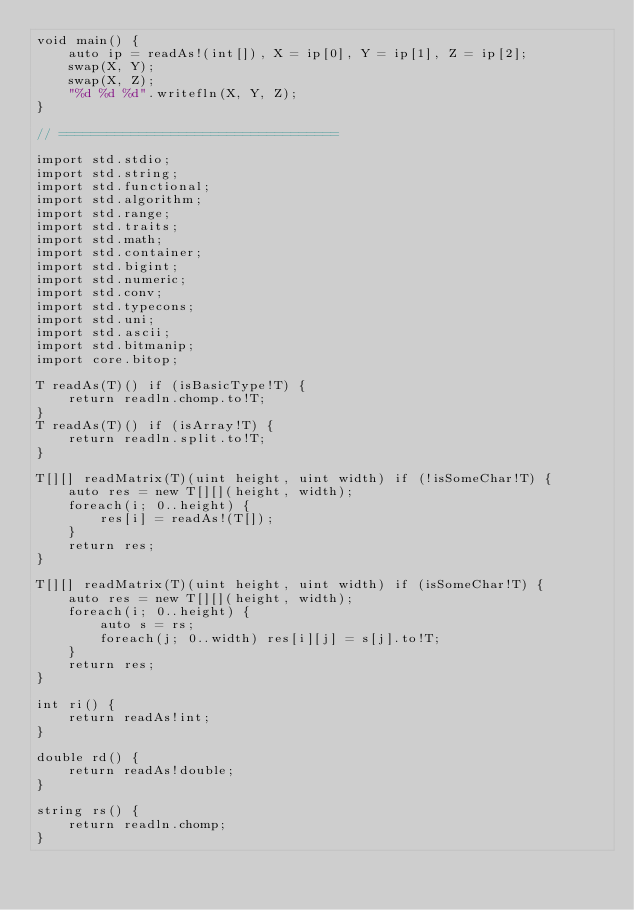Convert code to text. <code><loc_0><loc_0><loc_500><loc_500><_D_>void main() {
	auto ip = readAs!(int[]), X = ip[0], Y = ip[1], Z = ip[2];
	swap(X, Y);
	swap(X, Z);
	"%d %d %d".writefln(X, Y, Z);
}

// ===================================

import std.stdio;
import std.string;
import std.functional;
import std.algorithm;
import std.range;
import std.traits;
import std.math;
import std.container;
import std.bigint;
import std.numeric;
import std.conv;
import std.typecons;
import std.uni;
import std.ascii;
import std.bitmanip;
import core.bitop;

T readAs(T)() if (isBasicType!T) {
	return readln.chomp.to!T;
}
T readAs(T)() if (isArray!T) {
	return readln.split.to!T;
}

T[][] readMatrix(T)(uint height, uint width) if (!isSomeChar!T) {
	auto res = new T[][](height, width);
	foreach(i; 0..height) {
		res[i] = readAs!(T[]);
	}
	return res;
}

T[][] readMatrix(T)(uint height, uint width) if (isSomeChar!T) {
	auto res = new T[][](height, width);
	foreach(i; 0..height) {
		auto s = rs;
		foreach(j; 0..width) res[i][j] = s[j].to!T;
	}
	return res;
}

int ri() {
	return readAs!int;
}

double rd() {
	return readAs!double;
}

string rs() {
	return readln.chomp;
}</code> 